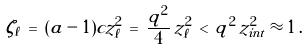<formula> <loc_0><loc_0><loc_500><loc_500>\zeta _ { \ell } \, = \, ( a - 1 ) c z _ { \ell } ^ { 2 } \, = \, \frac { q ^ { 2 } } { 4 } \, z _ { \ell } ^ { 2 } \, < \, q ^ { 2 } \, z _ { i n t } ^ { 2 } \approx 1 \, .</formula> 